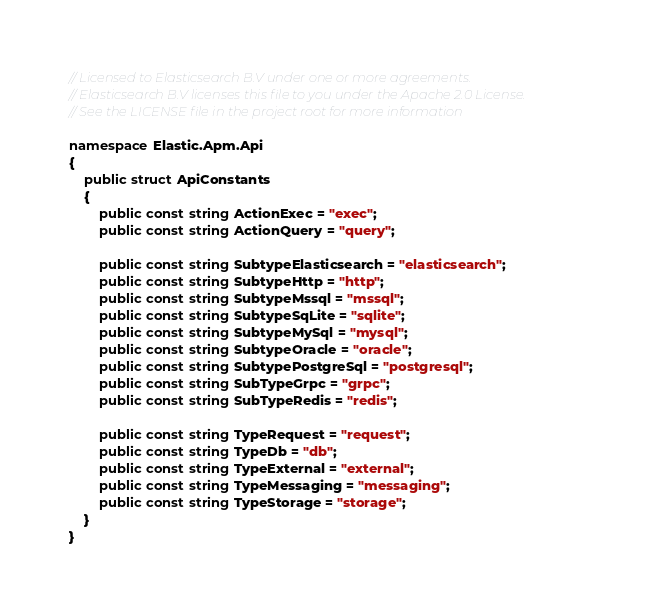Convert code to text. <code><loc_0><loc_0><loc_500><loc_500><_C#_>// Licensed to Elasticsearch B.V under one or more agreements.
// Elasticsearch B.V licenses this file to you under the Apache 2.0 License.
// See the LICENSE file in the project root for more information

namespace Elastic.Apm.Api
{
	public struct ApiConstants
	{
		public const string ActionExec = "exec";
		public const string ActionQuery = "query";

		public const string SubtypeElasticsearch = "elasticsearch";
		public const string SubtypeHttp = "http";
		public const string SubtypeMssql = "mssql";
		public const string SubtypeSqLite = "sqlite";
		public const string SubtypeMySql = "mysql";
		public const string SubtypeOracle = "oracle";
		public const string SubtypePostgreSql = "postgresql";
		public const string SubTypeGrpc = "grpc";
		public const string SubTypeRedis = "redis";

		public const string TypeRequest = "request";
		public const string TypeDb = "db";
		public const string TypeExternal = "external";
		public const string TypeMessaging = "messaging";
		public const string TypeStorage = "storage";
	}
}
</code> 